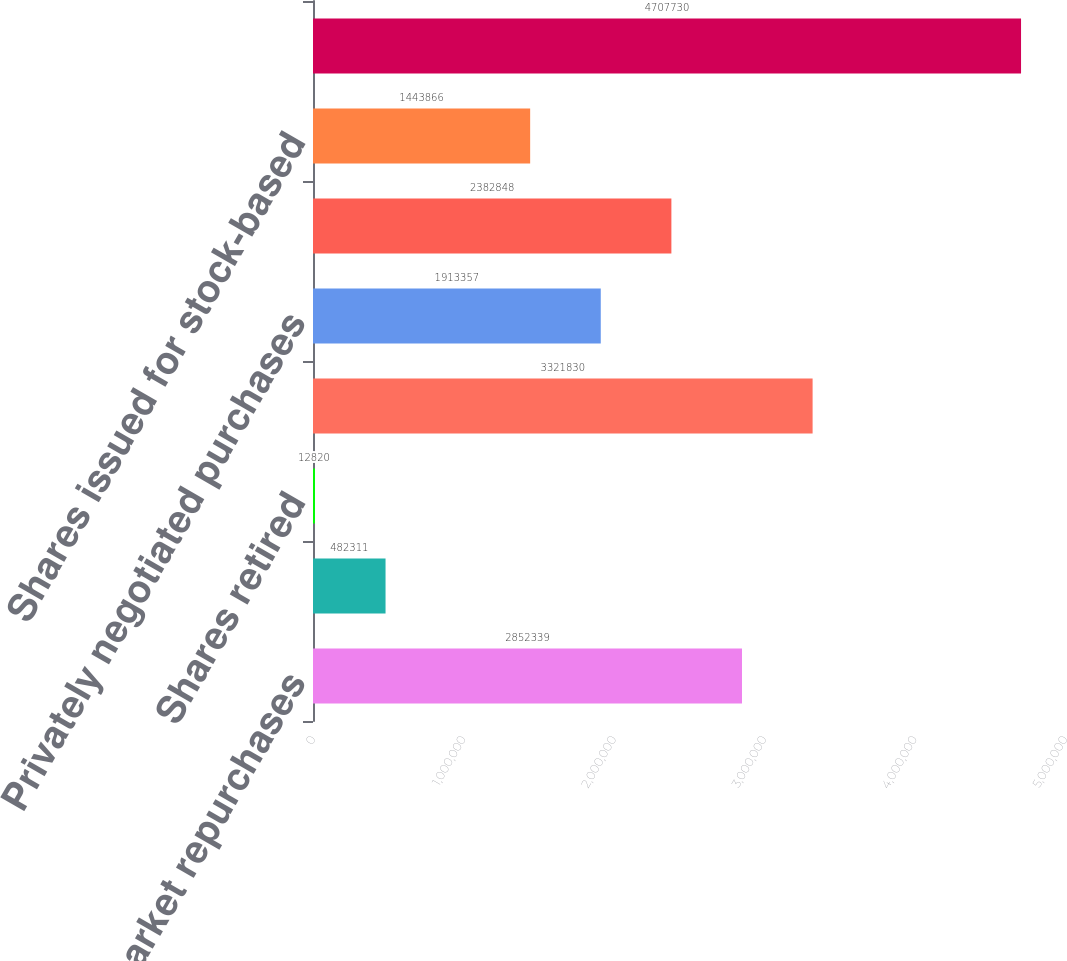<chart> <loc_0><loc_0><loc_500><loc_500><bar_chart><fcel>Open market repurchases<fcel>Repurchases from the Milton<fcel>Shares retired<fcel>Total repurchases under<fcel>Privately negotiated purchases<fcel>Shares repurchased to replace<fcel>Shares issued for stock-based<fcel>Total held as Treasury Stock<nl><fcel>2.85234e+06<fcel>482311<fcel>12820<fcel>3.32183e+06<fcel>1.91336e+06<fcel>2.38285e+06<fcel>1.44387e+06<fcel>4.70773e+06<nl></chart> 